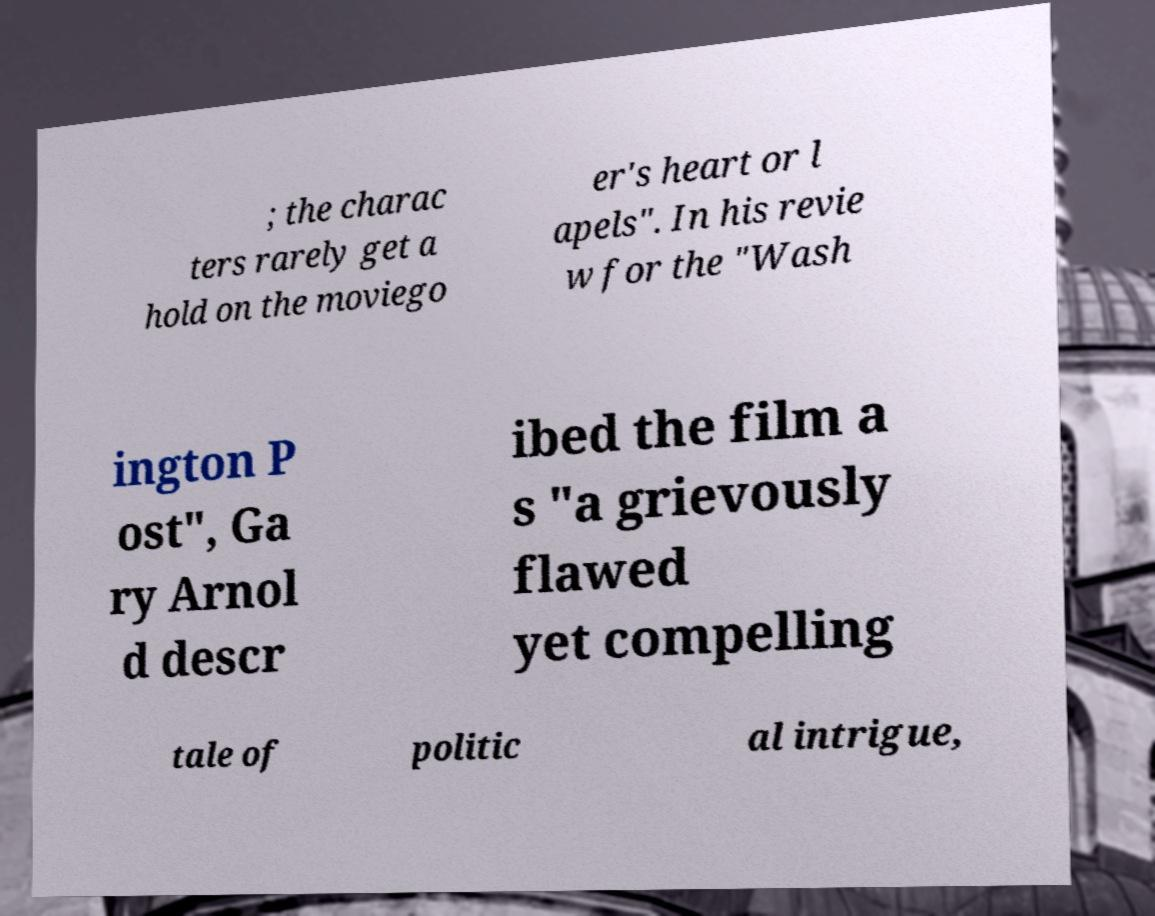Can you accurately transcribe the text from the provided image for me? ; the charac ters rarely get a hold on the moviego er's heart or l apels". In his revie w for the "Wash ington P ost", Ga ry Arnol d descr ibed the film a s "a grievously flawed yet compelling tale of politic al intrigue, 